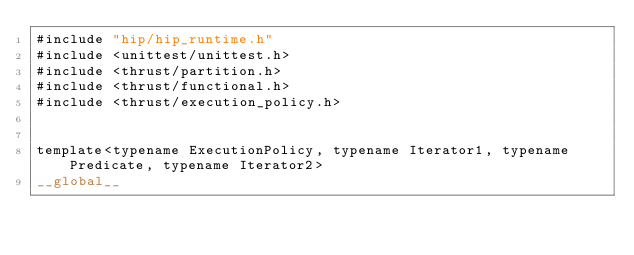<code> <loc_0><loc_0><loc_500><loc_500><_Cuda_>#include "hip/hip_runtime.h"
#include <unittest/unittest.h>
#include <thrust/partition.h>
#include <thrust/functional.h>
#include <thrust/execution_policy.h>


template<typename ExecutionPolicy, typename Iterator1, typename Predicate, typename Iterator2>
__global__</code> 